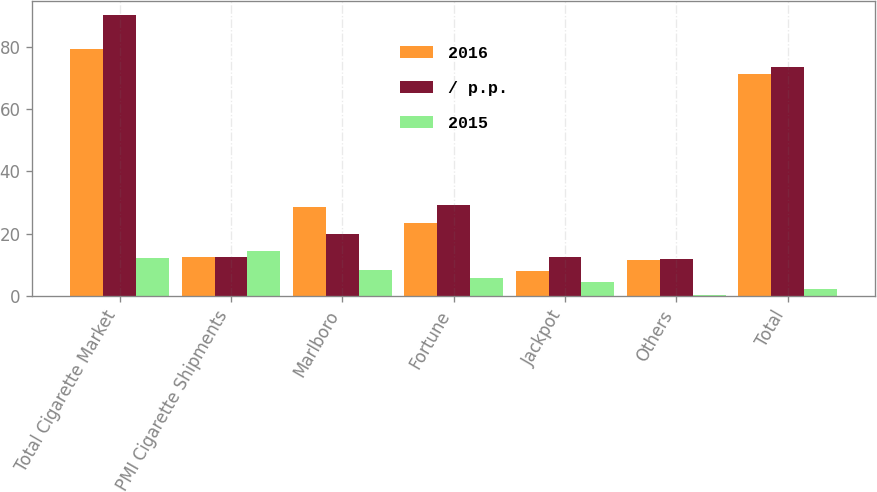<chart> <loc_0><loc_0><loc_500><loc_500><stacked_bar_chart><ecel><fcel>Total Cigarette Market<fcel>PMI Cigarette Shipments<fcel>Marlboro<fcel>Fortune<fcel>Jackpot<fcel>Others<fcel>Total<nl><fcel>2016<fcel>79.3<fcel>12.4<fcel>28.4<fcel>23.4<fcel>7.9<fcel>11.6<fcel>71.3<nl><fcel>/ p.p.<fcel>90.2<fcel>12.4<fcel>20<fcel>29.2<fcel>12.4<fcel>11.8<fcel>73.4<nl><fcel>2015<fcel>12<fcel>14.5<fcel>8.4<fcel>5.8<fcel>4.5<fcel>0.2<fcel>2.1<nl></chart> 